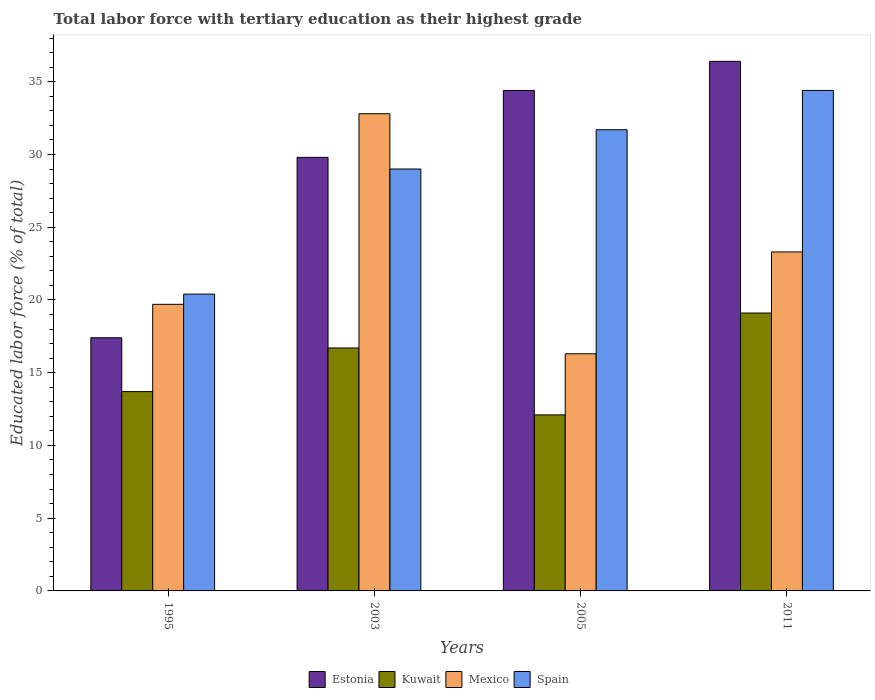Are the number of bars per tick equal to the number of legend labels?
Provide a succinct answer. Yes. How many bars are there on the 1st tick from the right?
Give a very brief answer. 4. What is the percentage of male labor force with tertiary education in Spain in 2003?
Your answer should be compact. 29. Across all years, what is the maximum percentage of male labor force with tertiary education in Mexico?
Make the answer very short. 32.8. Across all years, what is the minimum percentage of male labor force with tertiary education in Estonia?
Your answer should be compact. 17.4. In which year was the percentage of male labor force with tertiary education in Mexico maximum?
Make the answer very short. 2003. What is the total percentage of male labor force with tertiary education in Estonia in the graph?
Keep it short and to the point. 118. What is the difference between the percentage of male labor force with tertiary education in Mexico in 1995 and that in 2003?
Your response must be concise. -13.1. What is the difference between the percentage of male labor force with tertiary education in Estonia in 2011 and the percentage of male labor force with tertiary education in Kuwait in 2005?
Ensure brevity in your answer.  24.3. What is the average percentage of male labor force with tertiary education in Spain per year?
Give a very brief answer. 28.88. In the year 2005, what is the difference between the percentage of male labor force with tertiary education in Mexico and percentage of male labor force with tertiary education in Estonia?
Provide a succinct answer. -18.1. What is the ratio of the percentage of male labor force with tertiary education in Kuwait in 2005 to that in 2011?
Your response must be concise. 0.63. Is the percentage of male labor force with tertiary education in Spain in 1995 less than that in 2011?
Ensure brevity in your answer.  Yes. Is the difference between the percentage of male labor force with tertiary education in Mexico in 1995 and 2003 greater than the difference between the percentage of male labor force with tertiary education in Estonia in 1995 and 2003?
Your answer should be compact. No. What is the difference between the highest and the second highest percentage of male labor force with tertiary education in Kuwait?
Provide a short and direct response. 2.4. What is the difference between the highest and the lowest percentage of male labor force with tertiary education in Kuwait?
Offer a very short reply. 7. What does the 3rd bar from the left in 2011 represents?
Offer a terse response. Mexico. What does the 2nd bar from the right in 2003 represents?
Ensure brevity in your answer.  Mexico. Is it the case that in every year, the sum of the percentage of male labor force with tertiary education in Estonia and percentage of male labor force with tertiary education in Kuwait is greater than the percentage of male labor force with tertiary education in Spain?
Ensure brevity in your answer.  Yes. How many bars are there?
Ensure brevity in your answer.  16. Are the values on the major ticks of Y-axis written in scientific E-notation?
Ensure brevity in your answer.  No. Does the graph contain any zero values?
Keep it short and to the point. No. Does the graph contain grids?
Give a very brief answer. No. Where does the legend appear in the graph?
Provide a short and direct response. Bottom center. How many legend labels are there?
Offer a terse response. 4. What is the title of the graph?
Offer a very short reply. Total labor force with tertiary education as their highest grade. Does "Mongolia" appear as one of the legend labels in the graph?
Provide a succinct answer. No. What is the label or title of the X-axis?
Offer a terse response. Years. What is the label or title of the Y-axis?
Your answer should be very brief. Educated labor force (% of total). What is the Educated labor force (% of total) of Estonia in 1995?
Provide a succinct answer. 17.4. What is the Educated labor force (% of total) of Kuwait in 1995?
Your response must be concise. 13.7. What is the Educated labor force (% of total) in Mexico in 1995?
Your answer should be very brief. 19.7. What is the Educated labor force (% of total) of Spain in 1995?
Provide a short and direct response. 20.4. What is the Educated labor force (% of total) in Estonia in 2003?
Your answer should be very brief. 29.8. What is the Educated labor force (% of total) in Kuwait in 2003?
Keep it short and to the point. 16.7. What is the Educated labor force (% of total) in Mexico in 2003?
Offer a very short reply. 32.8. What is the Educated labor force (% of total) in Spain in 2003?
Your response must be concise. 29. What is the Educated labor force (% of total) in Estonia in 2005?
Give a very brief answer. 34.4. What is the Educated labor force (% of total) in Kuwait in 2005?
Your response must be concise. 12.1. What is the Educated labor force (% of total) in Mexico in 2005?
Your answer should be very brief. 16.3. What is the Educated labor force (% of total) of Spain in 2005?
Make the answer very short. 31.7. What is the Educated labor force (% of total) in Estonia in 2011?
Keep it short and to the point. 36.4. What is the Educated labor force (% of total) in Kuwait in 2011?
Provide a succinct answer. 19.1. What is the Educated labor force (% of total) in Mexico in 2011?
Your answer should be very brief. 23.3. What is the Educated labor force (% of total) of Spain in 2011?
Make the answer very short. 34.4. Across all years, what is the maximum Educated labor force (% of total) of Estonia?
Provide a short and direct response. 36.4. Across all years, what is the maximum Educated labor force (% of total) in Kuwait?
Your answer should be very brief. 19.1. Across all years, what is the maximum Educated labor force (% of total) of Mexico?
Your response must be concise. 32.8. Across all years, what is the maximum Educated labor force (% of total) in Spain?
Provide a short and direct response. 34.4. Across all years, what is the minimum Educated labor force (% of total) in Estonia?
Your answer should be compact. 17.4. Across all years, what is the minimum Educated labor force (% of total) in Kuwait?
Offer a terse response. 12.1. Across all years, what is the minimum Educated labor force (% of total) in Mexico?
Provide a short and direct response. 16.3. Across all years, what is the minimum Educated labor force (% of total) in Spain?
Offer a terse response. 20.4. What is the total Educated labor force (% of total) of Estonia in the graph?
Your response must be concise. 118. What is the total Educated labor force (% of total) in Kuwait in the graph?
Your answer should be very brief. 61.6. What is the total Educated labor force (% of total) in Mexico in the graph?
Ensure brevity in your answer.  92.1. What is the total Educated labor force (% of total) in Spain in the graph?
Give a very brief answer. 115.5. What is the difference between the Educated labor force (% of total) in Estonia in 1995 and that in 2003?
Give a very brief answer. -12.4. What is the difference between the Educated labor force (% of total) of Estonia in 1995 and that in 2005?
Ensure brevity in your answer.  -17. What is the difference between the Educated labor force (% of total) of Kuwait in 1995 and that in 2005?
Offer a very short reply. 1.6. What is the difference between the Educated labor force (% of total) of Estonia in 1995 and that in 2011?
Your answer should be very brief. -19. What is the difference between the Educated labor force (% of total) in Kuwait in 1995 and that in 2011?
Offer a terse response. -5.4. What is the difference between the Educated labor force (% of total) in Mexico in 1995 and that in 2011?
Ensure brevity in your answer.  -3.6. What is the difference between the Educated labor force (% of total) of Estonia in 2003 and that in 2005?
Keep it short and to the point. -4.6. What is the difference between the Educated labor force (% of total) of Kuwait in 2003 and that in 2005?
Your response must be concise. 4.6. What is the difference between the Educated labor force (% of total) of Spain in 2003 and that in 2005?
Ensure brevity in your answer.  -2.7. What is the difference between the Educated labor force (% of total) in Kuwait in 2003 and that in 2011?
Your answer should be compact. -2.4. What is the difference between the Educated labor force (% of total) in Mexico in 2003 and that in 2011?
Offer a very short reply. 9.5. What is the difference between the Educated labor force (% of total) in Spain in 2003 and that in 2011?
Provide a short and direct response. -5.4. What is the difference between the Educated labor force (% of total) of Kuwait in 2005 and that in 2011?
Make the answer very short. -7. What is the difference between the Educated labor force (% of total) in Estonia in 1995 and the Educated labor force (% of total) in Kuwait in 2003?
Your answer should be compact. 0.7. What is the difference between the Educated labor force (% of total) in Estonia in 1995 and the Educated labor force (% of total) in Mexico in 2003?
Give a very brief answer. -15.4. What is the difference between the Educated labor force (% of total) in Estonia in 1995 and the Educated labor force (% of total) in Spain in 2003?
Offer a terse response. -11.6. What is the difference between the Educated labor force (% of total) of Kuwait in 1995 and the Educated labor force (% of total) of Mexico in 2003?
Your answer should be compact. -19.1. What is the difference between the Educated labor force (% of total) of Kuwait in 1995 and the Educated labor force (% of total) of Spain in 2003?
Keep it short and to the point. -15.3. What is the difference between the Educated labor force (% of total) of Estonia in 1995 and the Educated labor force (% of total) of Spain in 2005?
Provide a short and direct response. -14.3. What is the difference between the Educated labor force (% of total) of Kuwait in 1995 and the Educated labor force (% of total) of Spain in 2005?
Offer a terse response. -18. What is the difference between the Educated labor force (% of total) of Mexico in 1995 and the Educated labor force (% of total) of Spain in 2005?
Provide a succinct answer. -12. What is the difference between the Educated labor force (% of total) in Estonia in 1995 and the Educated labor force (% of total) in Kuwait in 2011?
Your response must be concise. -1.7. What is the difference between the Educated labor force (% of total) in Estonia in 1995 and the Educated labor force (% of total) in Spain in 2011?
Your answer should be compact. -17. What is the difference between the Educated labor force (% of total) of Kuwait in 1995 and the Educated labor force (% of total) of Spain in 2011?
Your answer should be very brief. -20.7. What is the difference between the Educated labor force (% of total) in Mexico in 1995 and the Educated labor force (% of total) in Spain in 2011?
Offer a very short reply. -14.7. What is the difference between the Educated labor force (% of total) of Estonia in 2003 and the Educated labor force (% of total) of Kuwait in 2005?
Ensure brevity in your answer.  17.7. What is the difference between the Educated labor force (% of total) of Kuwait in 2003 and the Educated labor force (% of total) of Spain in 2005?
Ensure brevity in your answer.  -15. What is the difference between the Educated labor force (% of total) in Estonia in 2003 and the Educated labor force (% of total) in Mexico in 2011?
Provide a succinct answer. 6.5. What is the difference between the Educated labor force (% of total) of Estonia in 2003 and the Educated labor force (% of total) of Spain in 2011?
Keep it short and to the point. -4.6. What is the difference between the Educated labor force (% of total) in Kuwait in 2003 and the Educated labor force (% of total) in Spain in 2011?
Your answer should be very brief. -17.7. What is the difference between the Educated labor force (% of total) of Estonia in 2005 and the Educated labor force (% of total) of Kuwait in 2011?
Your response must be concise. 15.3. What is the difference between the Educated labor force (% of total) in Kuwait in 2005 and the Educated labor force (% of total) in Mexico in 2011?
Ensure brevity in your answer.  -11.2. What is the difference between the Educated labor force (% of total) of Kuwait in 2005 and the Educated labor force (% of total) of Spain in 2011?
Ensure brevity in your answer.  -22.3. What is the difference between the Educated labor force (% of total) of Mexico in 2005 and the Educated labor force (% of total) of Spain in 2011?
Offer a very short reply. -18.1. What is the average Educated labor force (% of total) in Estonia per year?
Provide a short and direct response. 29.5. What is the average Educated labor force (% of total) of Kuwait per year?
Ensure brevity in your answer.  15.4. What is the average Educated labor force (% of total) of Mexico per year?
Your answer should be compact. 23.02. What is the average Educated labor force (% of total) in Spain per year?
Keep it short and to the point. 28.88. In the year 1995, what is the difference between the Educated labor force (% of total) in Estonia and Educated labor force (% of total) in Spain?
Your response must be concise. -3. In the year 1995, what is the difference between the Educated labor force (% of total) in Kuwait and Educated labor force (% of total) in Spain?
Make the answer very short. -6.7. In the year 2003, what is the difference between the Educated labor force (% of total) of Estonia and Educated labor force (% of total) of Kuwait?
Ensure brevity in your answer.  13.1. In the year 2003, what is the difference between the Educated labor force (% of total) in Kuwait and Educated labor force (% of total) in Mexico?
Offer a very short reply. -16.1. In the year 2003, what is the difference between the Educated labor force (% of total) of Kuwait and Educated labor force (% of total) of Spain?
Provide a succinct answer. -12.3. In the year 2003, what is the difference between the Educated labor force (% of total) in Mexico and Educated labor force (% of total) in Spain?
Offer a very short reply. 3.8. In the year 2005, what is the difference between the Educated labor force (% of total) of Estonia and Educated labor force (% of total) of Kuwait?
Offer a terse response. 22.3. In the year 2005, what is the difference between the Educated labor force (% of total) of Estonia and Educated labor force (% of total) of Spain?
Your response must be concise. 2.7. In the year 2005, what is the difference between the Educated labor force (% of total) of Kuwait and Educated labor force (% of total) of Spain?
Make the answer very short. -19.6. In the year 2005, what is the difference between the Educated labor force (% of total) of Mexico and Educated labor force (% of total) of Spain?
Provide a short and direct response. -15.4. In the year 2011, what is the difference between the Educated labor force (% of total) of Estonia and Educated labor force (% of total) of Spain?
Provide a succinct answer. 2. In the year 2011, what is the difference between the Educated labor force (% of total) of Kuwait and Educated labor force (% of total) of Spain?
Provide a succinct answer. -15.3. In the year 2011, what is the difference between the Educated labor force (% of total) of Mexico and Educated labor force (% of total) of Spain?
Make the answer very short. -11.1. What is the ratio of the Educated labor force (% of total) in Estonia in 1995 to that in 2003?
Your response must be concise. 0.58. What is the ratio of the Educated labor force (% of total) of Kuwait in 1995 to that in 2003?
Your answer should be compact. 0.82. What is the ratio of the Educated labor force (% of total) in Mexico in 1995 to that in 2003?
Your response must be concise. 0.6. What is the ratio of the Educated labor force (% of total) in Spain in 1995 to that in 2003?
Your response must be concise. 0.7. What is the ratio of the Educated labor force (% of total) in Estonia in 1995 to that in 2005?
Provide a succinct answer. 0.51. What is the ratio of the Educated labor force (% of total) in Kuwait in 1995 to that in 2005?
Offer a terse response. 1.13. What is the ratio of the Educated labor force (% of total) of Mexico in 1995 to that in 2005?
Your answer should be compact. 1.21. What is the ratio of the Educated labor force (% of total) in Spain in 1995 to that in 2005?
Provide a succinct answer. 0.64. What is the ratio of the Educated labor force (% of total) of Estonia in 1995 to that in 2011?
Ensure brevity in your answer.  0.48. What is the ratio of the Educated labor force (% of total) of Kuwait in 1995 to that in 2011?
Provide a short and direct response. 0.72. What is the ratio of the Educated labor force (% of total) in Mexico in 1995 to that in 2011?
Make the answer very short. 0.85. What is the ratio of the Educated labor force (% of total) of Spain in 1995 to that in 2011?
Give a very brief answer. 0.59. What is the ratio of the Educated labor force (% of total) in Estonia in 2003 to that in 2005?
Your answer should be compact. 0.87. What is the ratio of the Educated labor force (% of total) of Kuwait in 2003 to that in 2005?
Give a very brief answer. 1.38. What is the ratio of the Educated labor force (% of total) of Mexico in 2003 to that in 2005?
Your response must be concise. 2.01. What is the ratio of the Educated labor force (% of total) of Spain in 2003 to that in 2005?
Provide a short and direct response. 0.91. What is the ratio of the Educated labor force (% of total) of Estonia in 2003 to that in 2011?
Keep it short and to the point. 0.82. What is the ratio of the Educated labor force (% of total) in Kuwait in 2003 to that in 2011?
Make the answer very short. 0.87. What is the ratio of the Educated labor force (% of total) of Mexico in 2003 to that in 2011?
Your answer should be very brief. 1.41. What is the ratio of the Educated labor force (% of total) in Spain in 2003 to that in 2011?
Your response must be concise. 0.84. What is the ratio of the Educated labor force (% of total) in Estonia in 2005 to that in 2011?
Offer a terse response. 0.95. What is the ratio of the Educated labor force (% of total) of Kuwait in 2005 to that in 2011?
Ensure brevity in your answer.  0.63. What is the ratio of the Educated labor force (% of total) of Mexico in 2005 to that in 2011?
Make the answer very short. 0.7. What is the ratio of the Educated labor force (% of total) of Spain in 2005 to that in 2011?
Make the answer very short. 0.92. What is the difference between the highest and the second highest Educated labor force (% of total) of Estonia?
Make the answer very short. 2. What is the difference between the highest and the lowest Educated labor force (% of total) of Estonia?
Give a very brief answer. 19. What is the difference between the highest and the lowest Educated labor force (% of total) of Kuwait?
Ensure brevity in your answer.  7. What is the difference between the highest and the lowest Educated labor force (% of total) of Spain?
Your answer should be very brief. 14. 